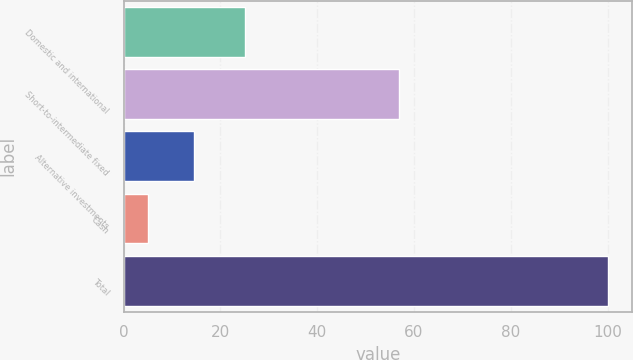Convert chart to OTSL. <chart><loc_0><loc_0><loc_500><loc_500><bar_chart><fcel>Domestic and international<fcel>Short-to-intermediate fixed<fcel>Alternative investments<fcel>Cash<fcel>Total<nl><fcel>25<fcel>57<fcel>14.5<fcel>5<fcel>100<nl></chart> 